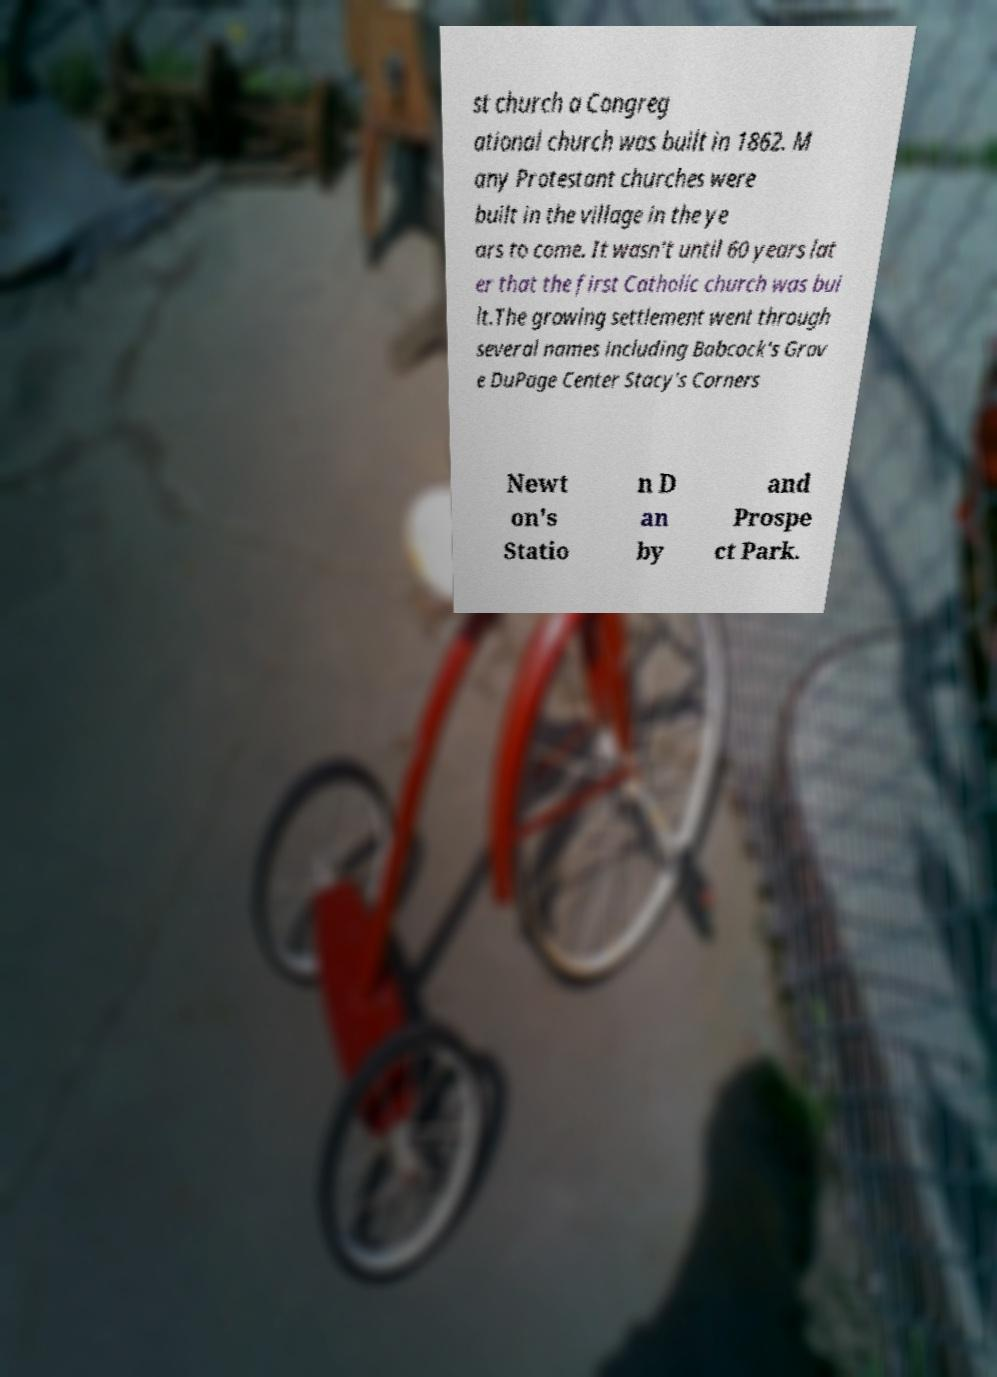Please identify and transcribe the text found in this image. st church a Congreg ational church was built in 1862. M any Protestant churches were built in the village in the ye ars to come. It wasn't until 60 years lat er that the first Catholic church was bui lt.The growing settlement went through several names including Babcock's Grov e DuPage Center Stacy's Corners Newt on's Statio n D an by and Prospe ct Park. 